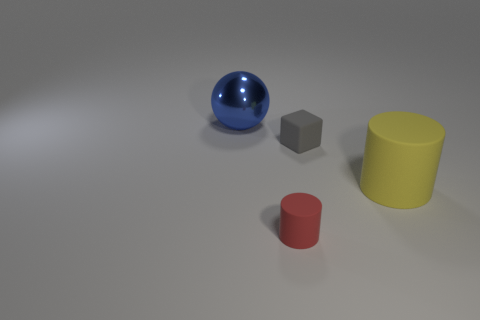Is there any other thing that is the same shape as the gray thing?
Give a very brief answer. No. What shape is the thing that is both behind the big matte object and in front of the blue metal thing?
Your response must be concise. Cube. What number of red metallic spheres are there?
Provide a succinct answer. 0. There is a small thing that is made of the same material as the small gray block; what color is it?
Provide a short and direct response. Red. Is the number of blue metal spheres greater than the number of large red metallic cubes?
Provide a succinct answer. Yes. How big is the thing that is behind the large yellow rubber cylinder and to the right of the red thing?
Ensure brevity in your answer.  Small. Are there an equal number of large shiny things that are on the right side of the large yellow cylinder and small red rubber cylinders?
Provide a succinct answer. No. Does the sphere have the same size as the yellow rubber cylinder?
Your response must be concise. Yes. What color is the object that is left of the small gray matte block and in front of the blue thing?
Your response must be concise. Red. What material is the big thing that is to the left of the tiny rubber thing behind the yellow cylinder?
Your answer should be very brief. Metal. 